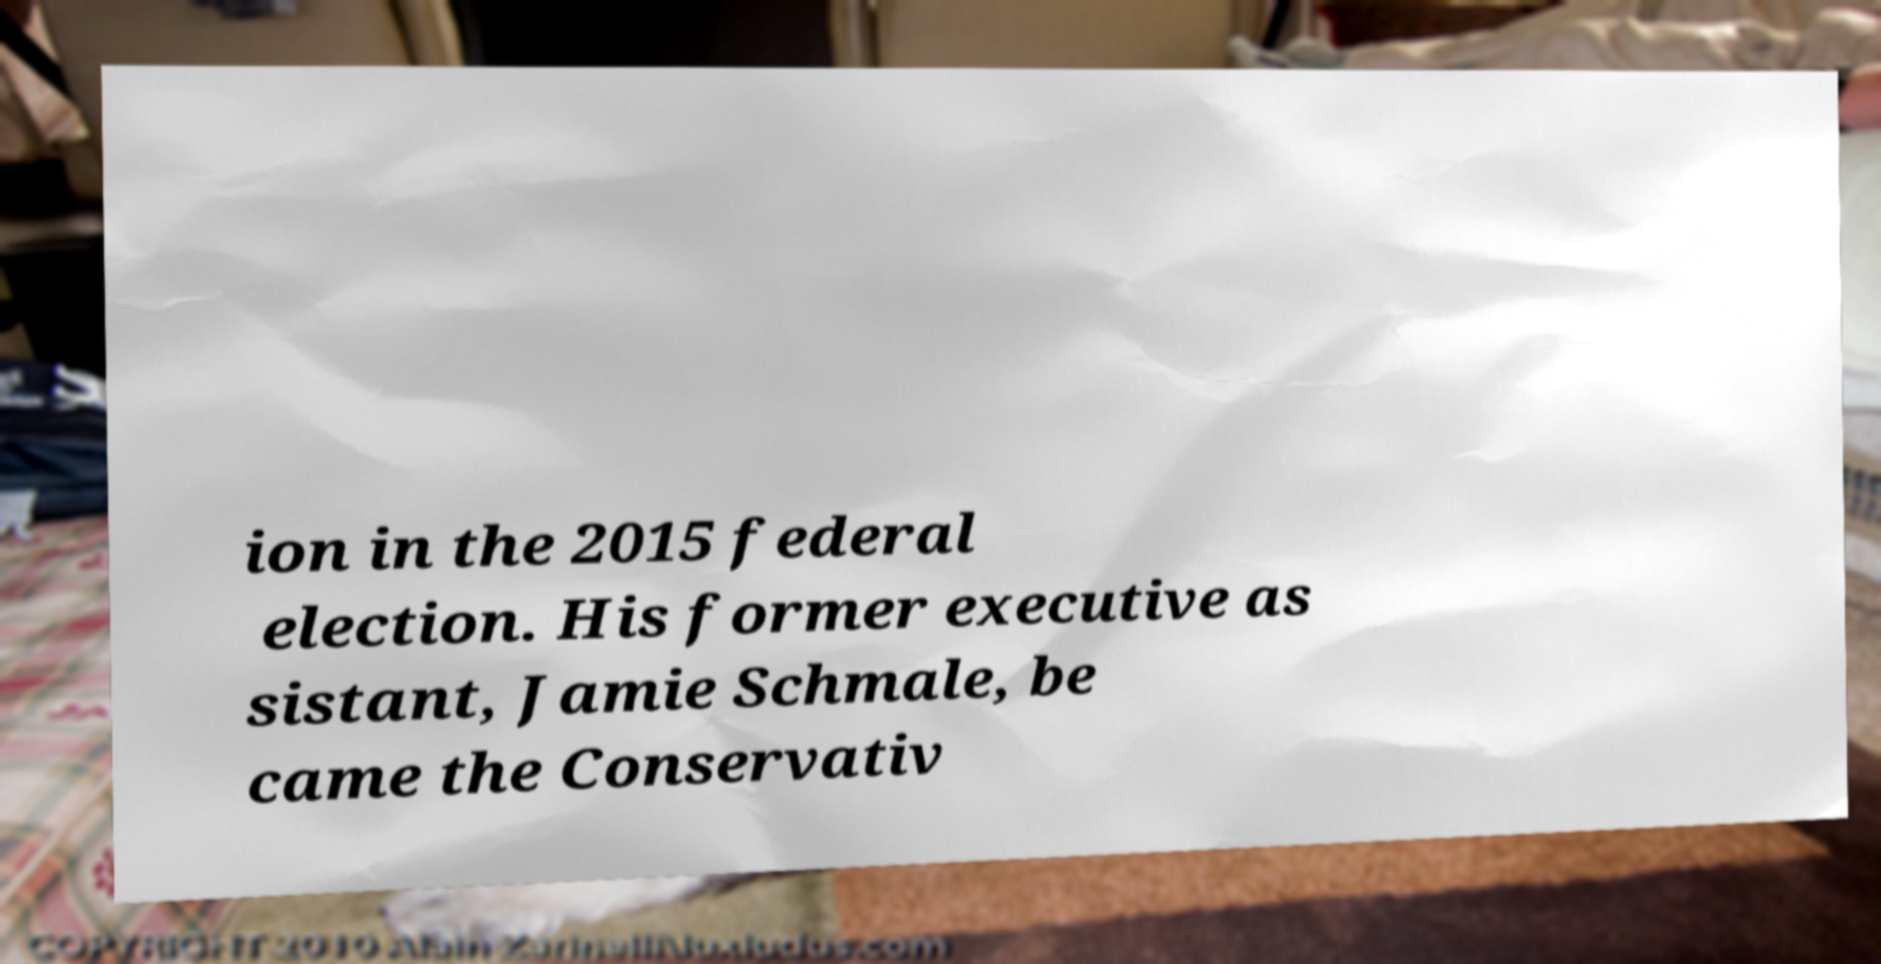Can you read and provide the text displayed in the image?This photo seems to have some interesting text. Can you extract and type it out for me? ion in the 2015 federal election. His former executive as sistant, Jamie Schmale, be came the Conservativ 